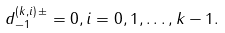<formula> <loc_0><loc_0><loc_500><loc_500>d ^ { ( k , i ) \, \pm } _ { - 1 } = 0 , i = 0 , 1 , \dots , k - 1 .</formula> 